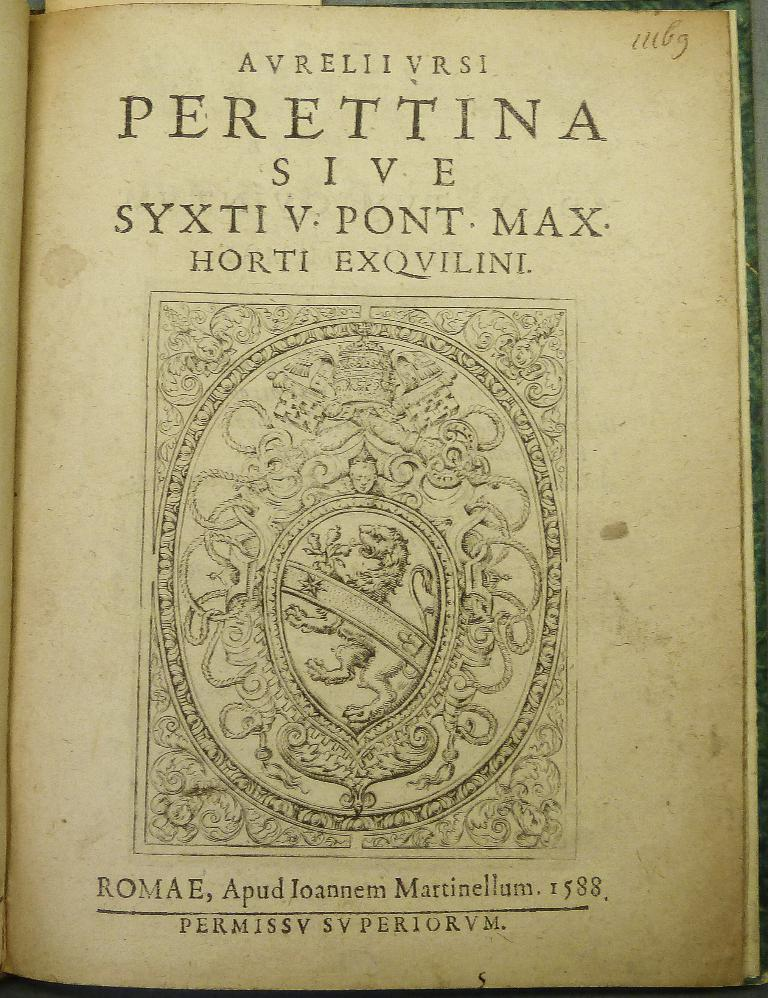<image>
Present a compact description of the photo's key features. An old book is open to the title page that says Perettina Sive. 